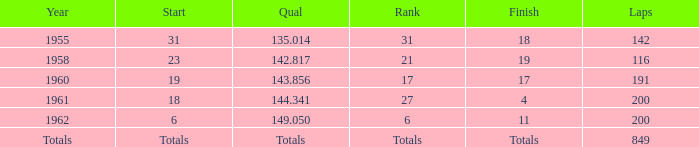What is the year with 116 laps? 1958.0. Could you parse the entire table? {'header': ['Year', 'Start', 'Qual', 'Rank', 'Finish', 'Laps'], 'rows': [['1955', '31', '135.014', '31', '18', '142'], ['1958', '23', '142.817', '21', '19', '116'], ['1960', '19', '143.856', '17', '17', '191'], ['1961', '18', '144.341', '27', '4', '200'], ['1962', '6', '149.050', '6', '11', '200'], ['Totals', 'Totals', 'Totals', 'Totals', 'Totals', '849']]} 